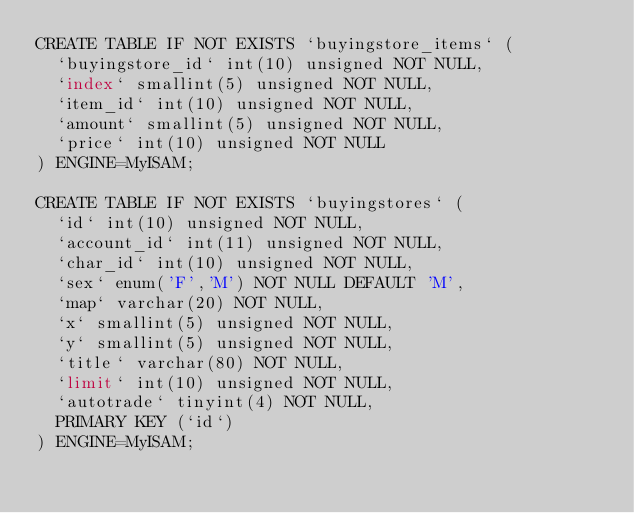Convert code to text. <code><loc_0><loc_0><loc_500><loc_500><_SQL_>CREATE TABLE IF NOT EXISTS `buyingstore_items` (
  `buyingstore_id` int(10) unsigned NOT NULL,
  `index` smallint(5) unsigned NOT NULL,
  `item_id` int(10) unsigned NOT NULL,
  `amount` smallint(5) unsigned NOT NULL,
  `price` int(10) unsigned NOT NULL
) ENGINE=MyISAM;

CREATE TABLE IF NOT EXISTS `buyingstores` (
  `id` int(10) unsigned NOT NULL,
  `account_id` int(11) unsigned NOT NULL,
  `char_id` int(10) unsigned NOT NULL,
  `sex` enum('F','M') NOT NULL DEFAULT 'M',
  `map` varchar(20) NOT NULL,
  `x` smallint(5) unsigned NOT NULL,
  `y` smallint(5) unsigned NOT NULL,
  `title` varchar(80) NOT NULL,
  `limit` int(10) unsigned NOT NULL,
  `autotrade` tinyint(4) NOT NULL,
  PRIMARY KEY (`id`)
) ENGINE=MyISAM;</code> 